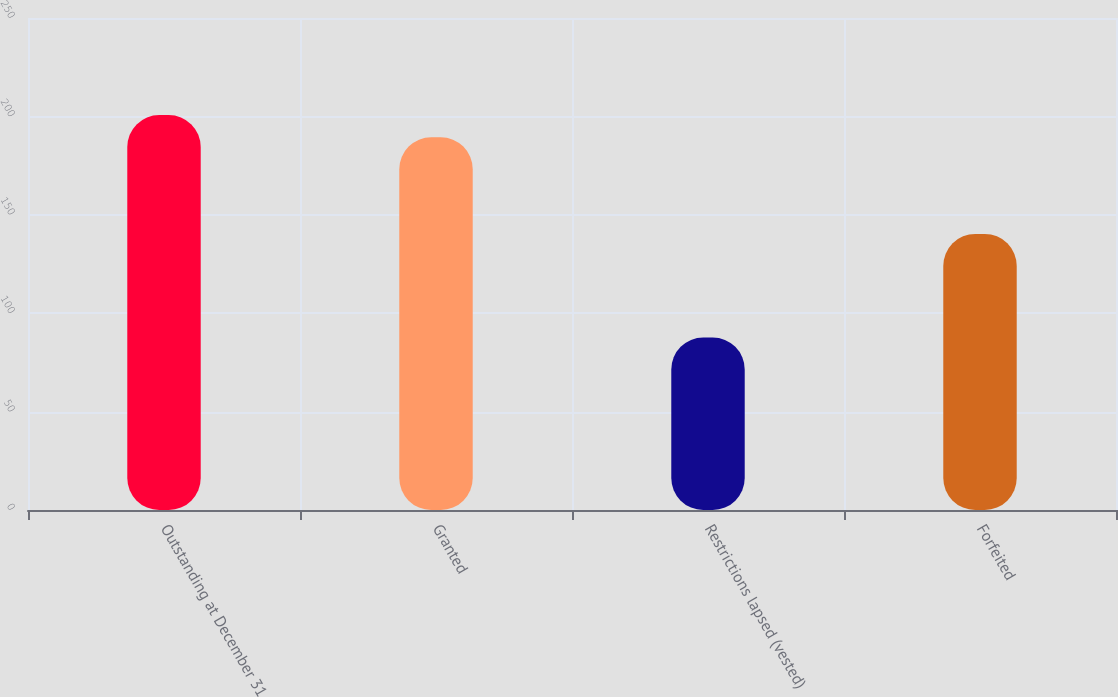Convert chart. <chart><loc_0><loc_0><loc_500><loc_500><bar_chart><fcel>Outstanding at December 31<fcel>Granted<fcel>Restrictions lapsed (vested)<fcel>Forfeited<nl><fcel>200.66<fcel>189.42<fcel>87.67<fcel>140.29<nl></chart> 